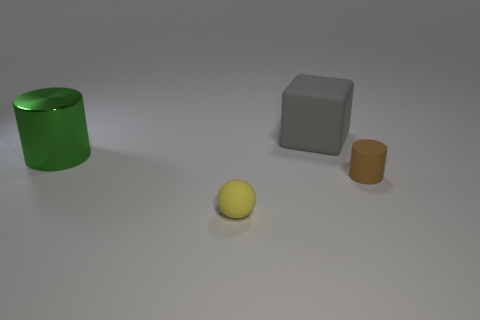Add 4 tiny cyan metal cubes. How many objects exist? 8 Subtract 1 cylinders. How many cylinders are left? 1 Subtract all cubes. How many objects are left? 3 Subtract 0 yellow cylinders. How many objects are left? 4 Subtract all green balls. Subtract all green cylinders. How many balls are left? 1 Subtract all rubber balls. Subtract all tiny objects. How many objects are left? 1 Add 4 brown cylinders. How many brown cylinders are left? 5 Add 3 yellow matte objects. How many yellow matte objects exist? 4 